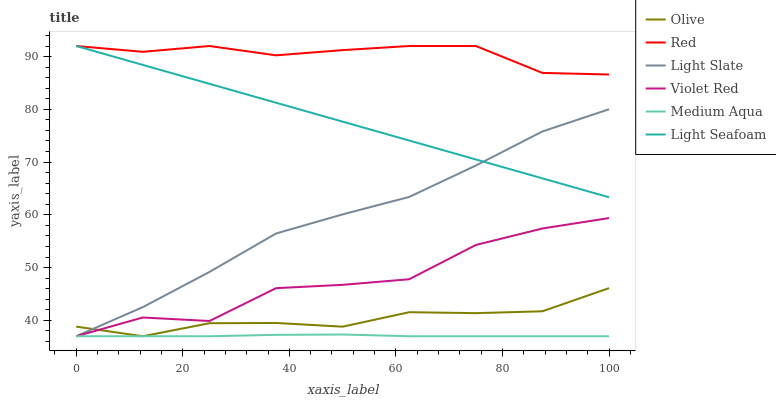Does Medium Aqua have the minimum area under the curve?
Answer yes or no. Yes. Does Red have the maximum area under the curve?
Answer yes or no. Yes. Does Light Slate have the minimum area under the curve?
Answer yes or no. No. Does Light Slate have the maximum area under the curve?
Answer yes or no. No. Is Light Seafoam the smoothest?
Answer yes or no. Yes. Is Violet Red the roughest?
Answer yes or no. Yes. Is Light Slate the smoothest?
Answer yes or no. No. Is Light Slate the roughest?
Answer yes or no. No. Does Light Seafoam have the lowest value?
Answer yes or no. No. Does Red have the highest value?
Answer yes or no. Yes. Does Light Slate have the highest value?
Answer yes or no. No. Is Violet Red less than Light Seafoam?
Answer yes or no. Yes. Is Red greater than Medium Aqua?
Answer yes or no. Yes. Does Violet Red intersect Light Seafoam?
Answer yes or no. No. 